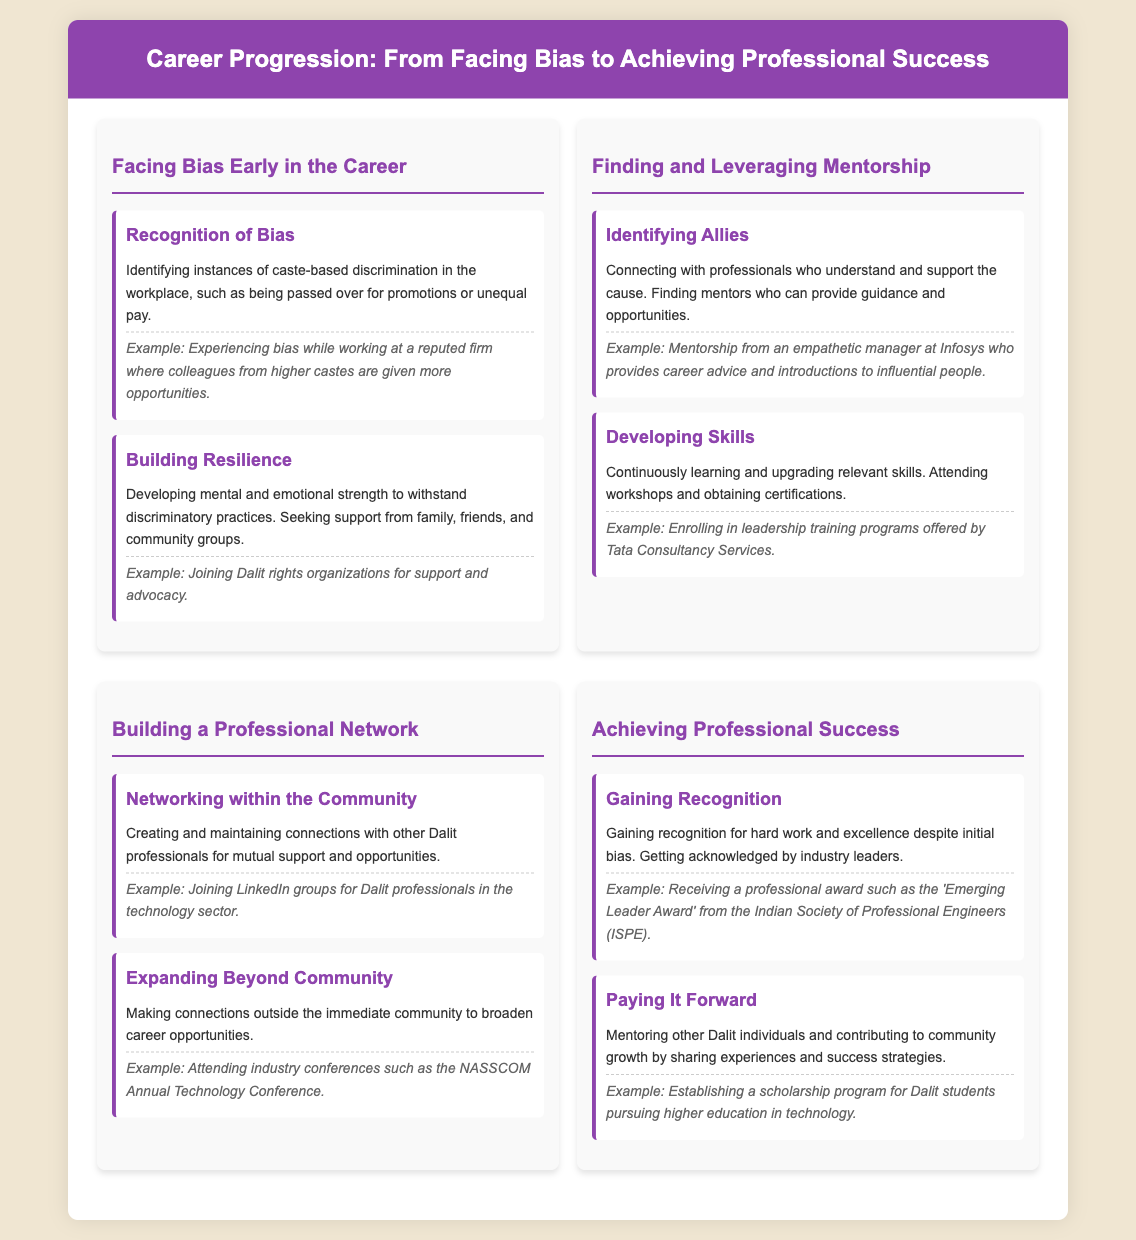What is the title of the document? The title is stated at the top of the document, which outlines the main theme.
Answer: Career Progression: From Facing Bias to Achieving Professional Success How many sections are there in the process? The document contains multiple distinct sections detailing different steps in career progression, which are categorized under major headings.
Answer: Four What is an example of 'Recognizing Bias'? An example is provided to illustrate the concept of bias experienced in the workplace and adds context to the discussion.
Answer: Experiencing bias while working at a reputed firm where colleagues from higher castes are given more opportunities What does 'Paying It Forward' refer to? The document explains this concept as a way to give back to the community and encourages sharing experiences to uplift others.
Answer: Mentoring other Dalit individuals and contributing to community growth by sharing experiences and success strategies Who can be a mentor according to the document? The text specifies the type of individuals who can help guide and support a professional's career journey, focusing on their understanding and support for the cause.
Answer: Professionals who understand and support the cause What kind of award is mentioned in the 'Gaining Recognition' section? The document gives a specific name of an award that signifies recognition in one's professional field.
Answer: Emerging Leader Award What organization is referenced for support in building resilience? This question addresses where one can seek support and advocacy, indicating the existence of networks or groups that provide help.
Answer: Dalit rights organizations What is the focus of the 'Expanding Beyond Community' step? This phrase summarizes an important strategy discussed for advancing one’s career and opportunities outside of one's immediate network.
Answer: Making connections outside the immediate community to broaden career opportunities 